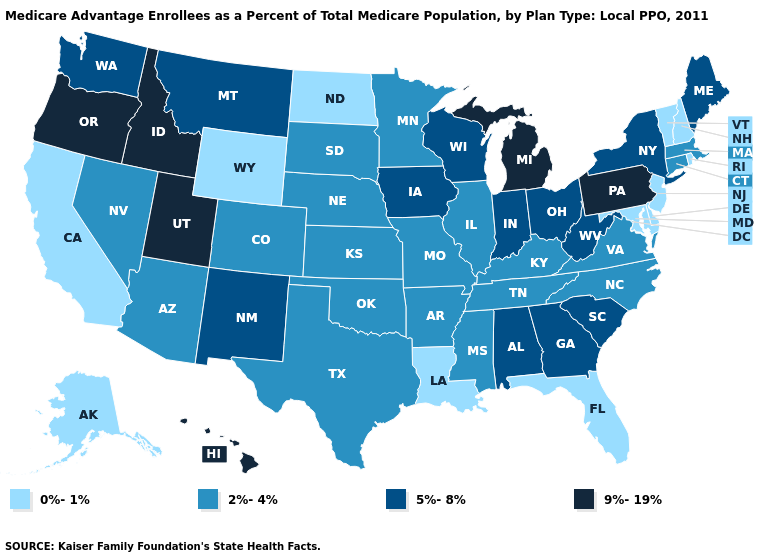Does Delaware have the highest value in the USA?
Give a very brief answer. No. Name the states that have a value in the range 5%-8%?
Give a very brief answer. Alabama, Georgia, Iowa, Indiana, Maine, Montana, New Mexico, New York, Ohio, South Carolina, Washington, Wisconsin, West Virginia. Name the states that have a value in the range 9%-19%?
Be succinct. Hawaii, Idaho, Michigan, Oregon, Pennsylvania, Utah. Does Connecticut have a lower value than Nebraska?
Concise answer only. No. What is the highest value in states that border Idaho?
Keep it brief. 9%-19%. Name the states that have a value in the range 2%-4%?
Answer briefly. Arkansas, Arizona, Colorado, Connecticut, Illinois, Kansas, Kentucky, Massachusetts, Minnesota, Missouri, Mississippi, North Carolina, Nebraska, Nevada, Oklahoma, South Dakota, Tennessee, Texas, Virginia. What is the value of Hawaii?
Write a very short answer. 9%-19%. What is the value of Wisconsin?
Answer briefly. 5%-8%. What is the lowest value in the USA?
Short answer required. 0%-1%. Among the states that border Texas , does Oklahoma have the highest value?
Give a very brief answer. No. What is the value of Idaho?
Answer briefly. 9%-19%. Does the first symbol in the legend represent the smallest category?
Give a very brief answer. Yes. What is the lowest value in the West?
Write a very short answer. 0%-1%. Name the states that have a value in the range 5%-8%?
Short answer required. Alabama, Georgia, Iowa, Indiana, Maine, Montana, New Mexico, New York, Ohio, South Carolina, Washington, Wisconsin, West Virginia. Which states hav the highest value in the South?
Answer briefly. Alabama, Georgia, South Carolina, West Virginia. 